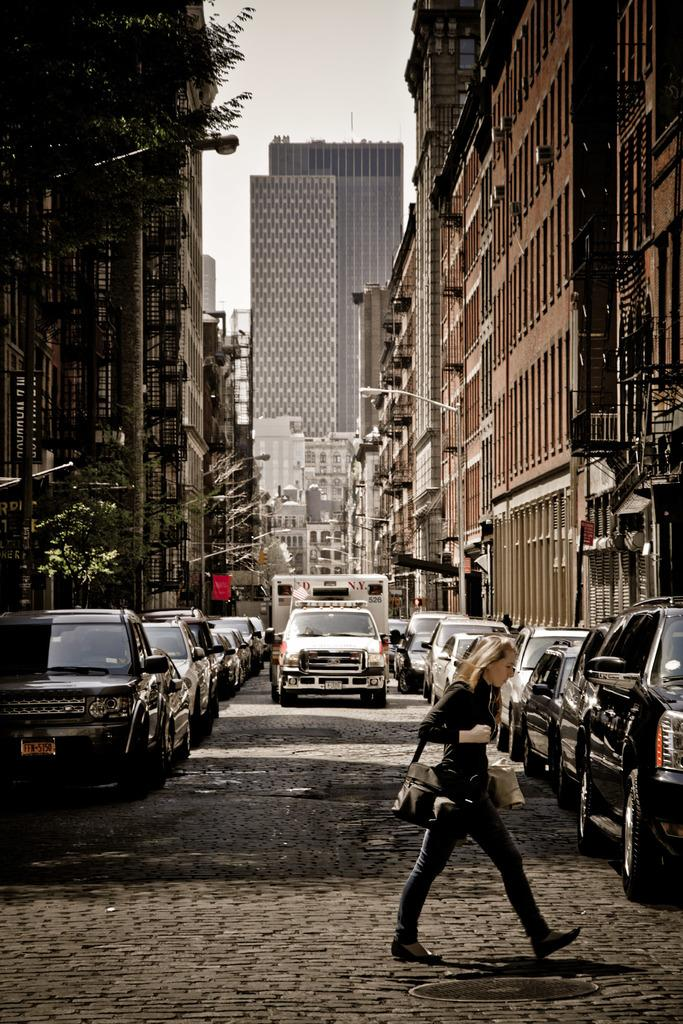<image>
Present a compact description of the photo's key features. a woman is crossing a brick street and a FDNY ambulance is driving toward her 